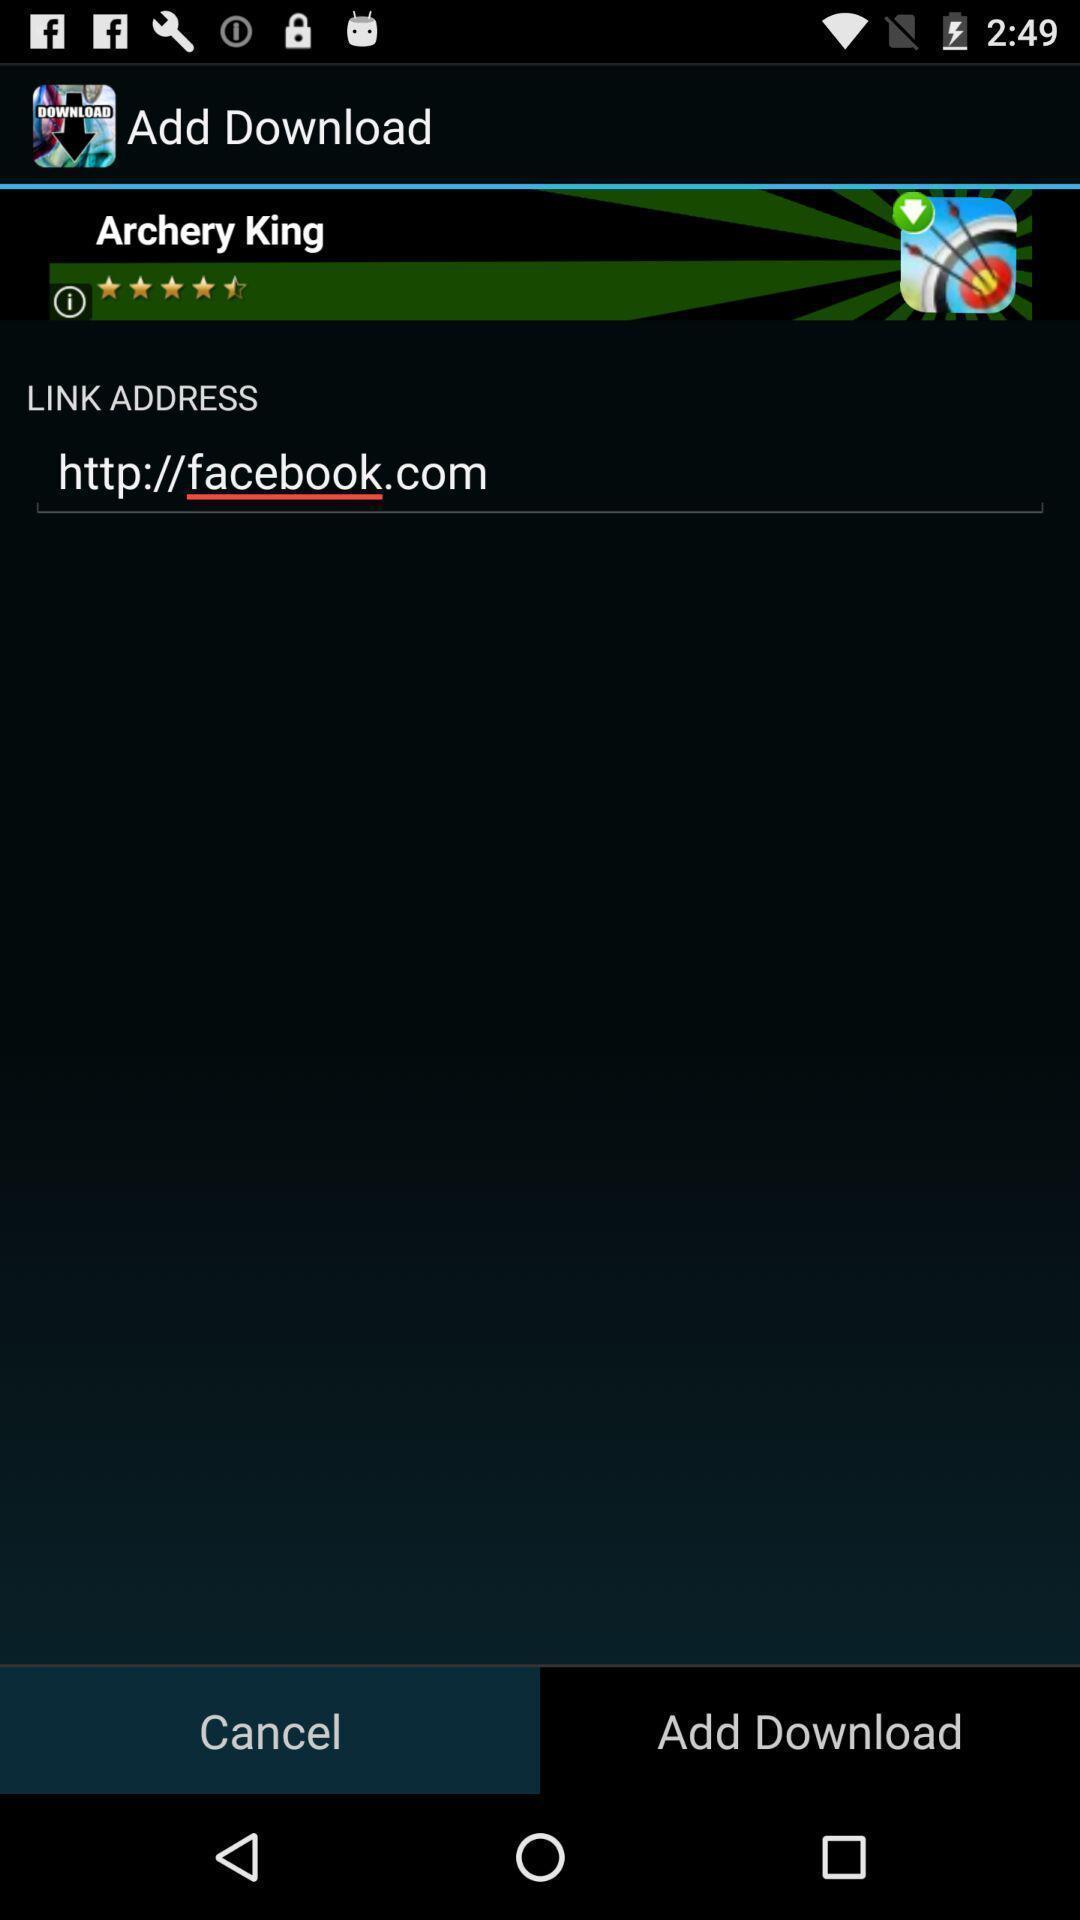Provide a detailed account of this screenshot. Page instructing to download an app. 